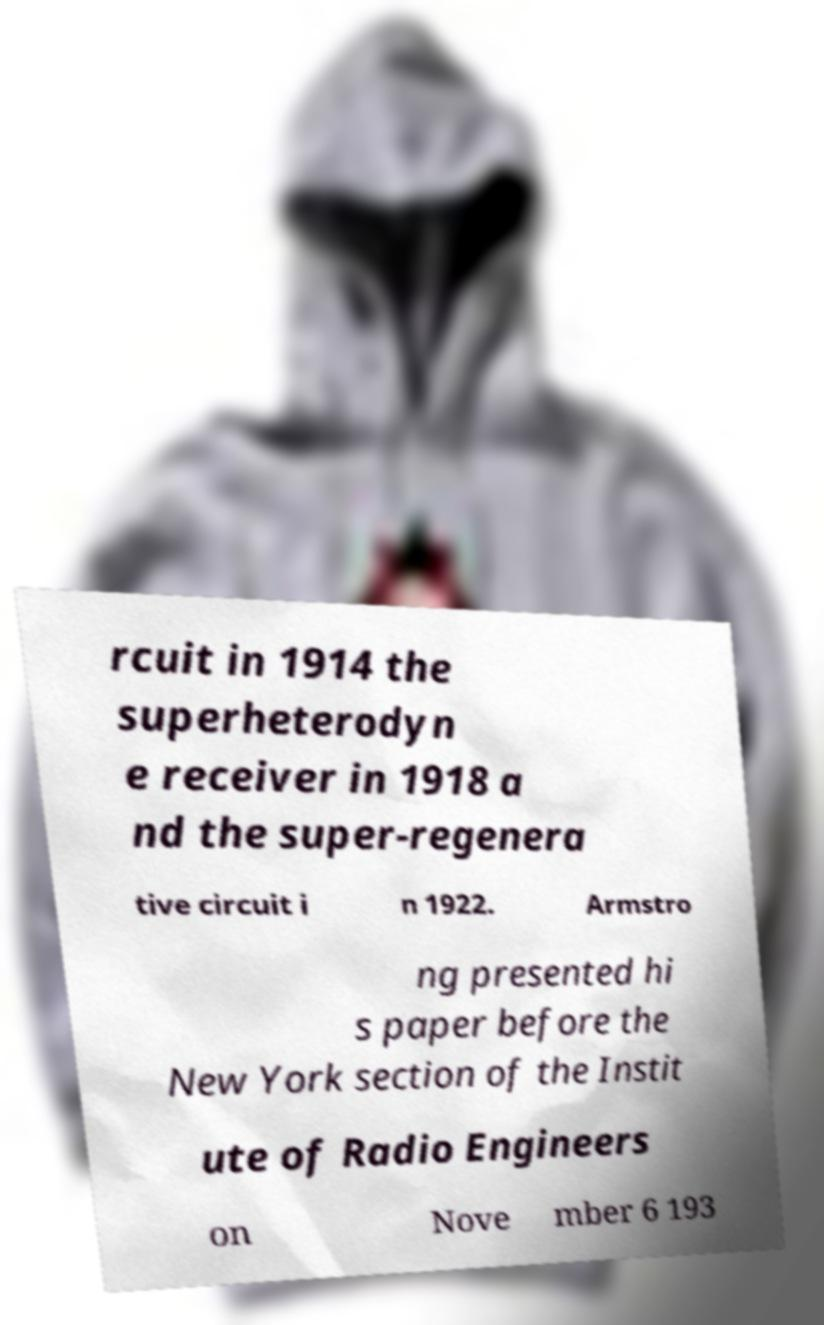Can you read and provide the text displayed in the image?This photo seems to have some interesting text. Can you extract and type it out for me? rcuit in 1914 the superheterodyn e receiver in 1918 a nd the super-regenera tive circuit i n 1922. Armstro ng presented hi s paper before the New York section of the Instit ute of Radio Engineers on Nove mber 6 193 